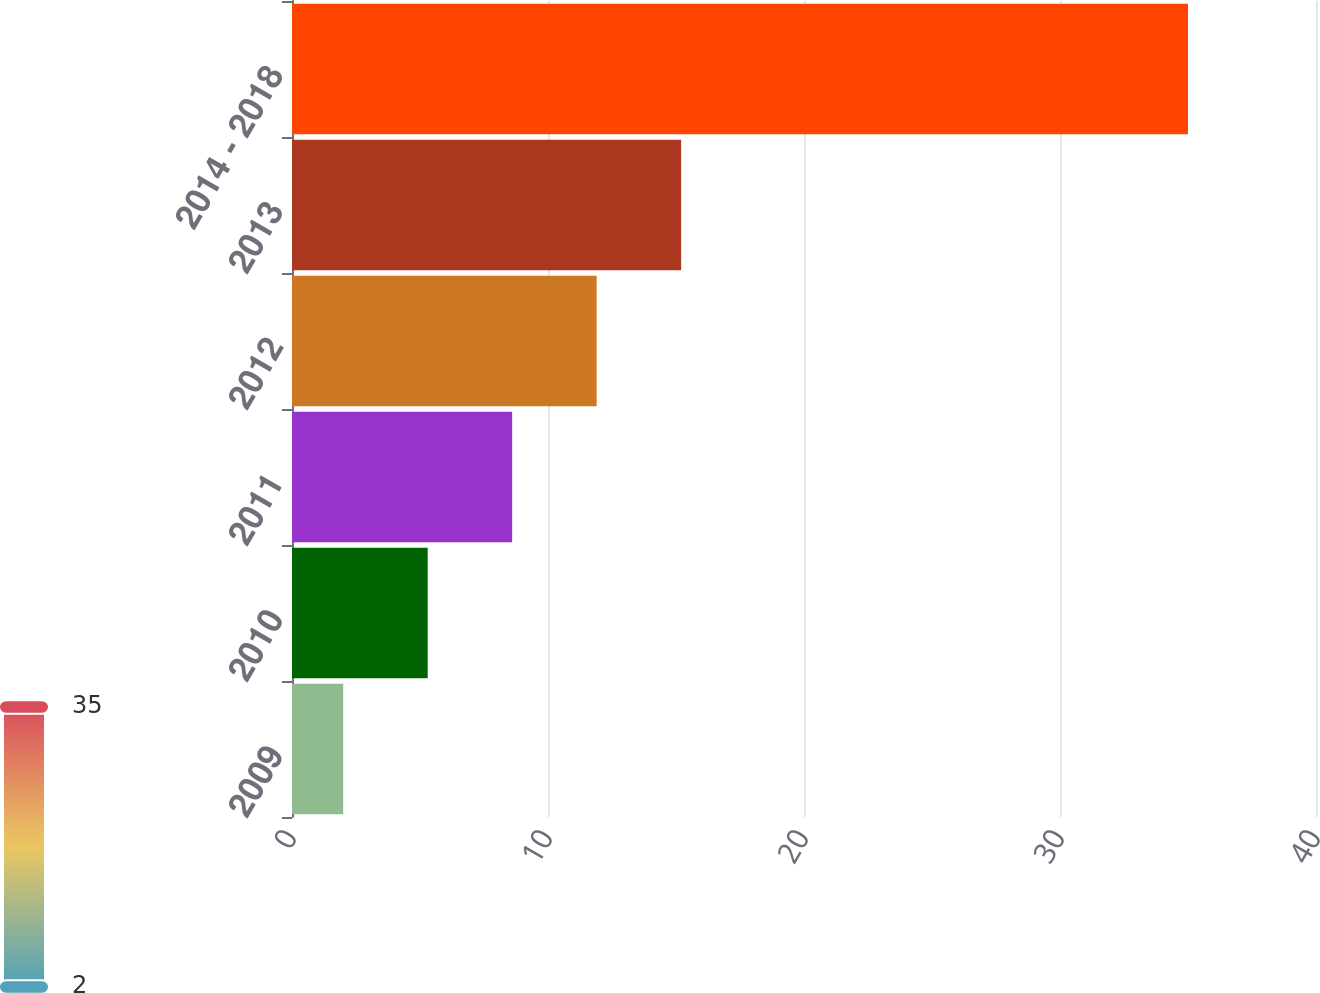Convert chart. <chart><loc_0><loc_0><loc_500><loc_500><bar_chart><fcel>2009<fcel>2010<fcel>2011<fcel>2012<fcel>2013<fcel>2014 - 2018<nl><fcel>2<fcel>5.3<fcel>8.6<fcel>11.9<fcel>15.2<fcel>35<nl></chart> 